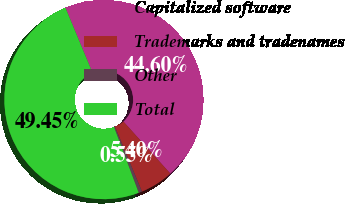Convert chart to OTSL. <chart><loc_0><loc_0><loc_500><loc_500><pie_chart><fcel>Capitalized software<fcel>Trademarks and tradenames<fcel>Other<fcel>Total<nl><fcel>44.6%<fcel>5.4%<fcel>0.55%<fcel>49.45%<nl></chart> 